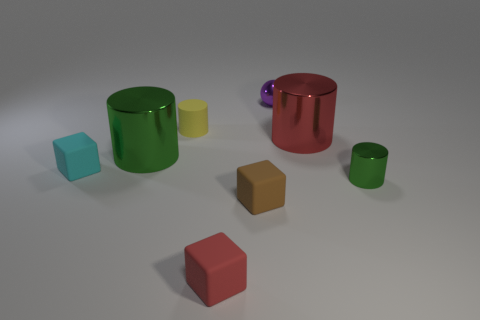What is the material of the large object that is right of the big green metallic cylinder?
Provide a succinct answer. Metal. Are there the same number of green cylinders that are in front of the tiny red object and large green metallic things?
Ensure brevity in your answer.  No. What is the red thing behind the small cube that is in front of the small brown matte block made of?
Your answer should be compact. Metal. What shape is the small object that is to the right of the brown rubber object and left of the tiny green object?
Keep it short and to the point. Sphere. What is the size of the yellow rubber thing that is the same shape as the red shiny thing?
Provide a succinct answer. Small. Is the number of small cylinders that are right of the small green thing less than the number of gray metal cubes?
Provide a short and direct response. No. How big is the green object that is on the right side of the tiny metal sphere?
Ensure brevity in your answer.  Small. What color is the other small object that is the same shape as the small yellow thing?
Give a very brief answer. Green. How many things have the same color as the tiny metallic cylinder?
Offer a terse response. 1. Is there anything else that has the same shape as the purple metal thing?
Provide a succinct answer. No. 